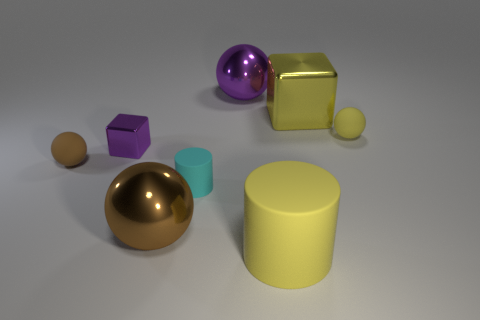Subtract all small yellow matte balls. How many balls are left? 3 Subtract all gray cylinders. How many brown balls are left? 2 Subtract all purple spheres. How many spheres are left? 3 Add 2 small cyan matte cylinders. How many objects exist? 10 Subtract all purple balls. Subtract all gray cubes. How many balls are left? 3 Subtract all cubes. How many objects are left? 6 Add 2 large purple shiny things. How many large purple shiny things are left? 3 Add 4 cyan things. How many cyan things exist? 5 Subtract 2 brown balls. How many objects are left? 6 Subtract all big objects. Subtract all red matte cubes. How many objects are left? 4 